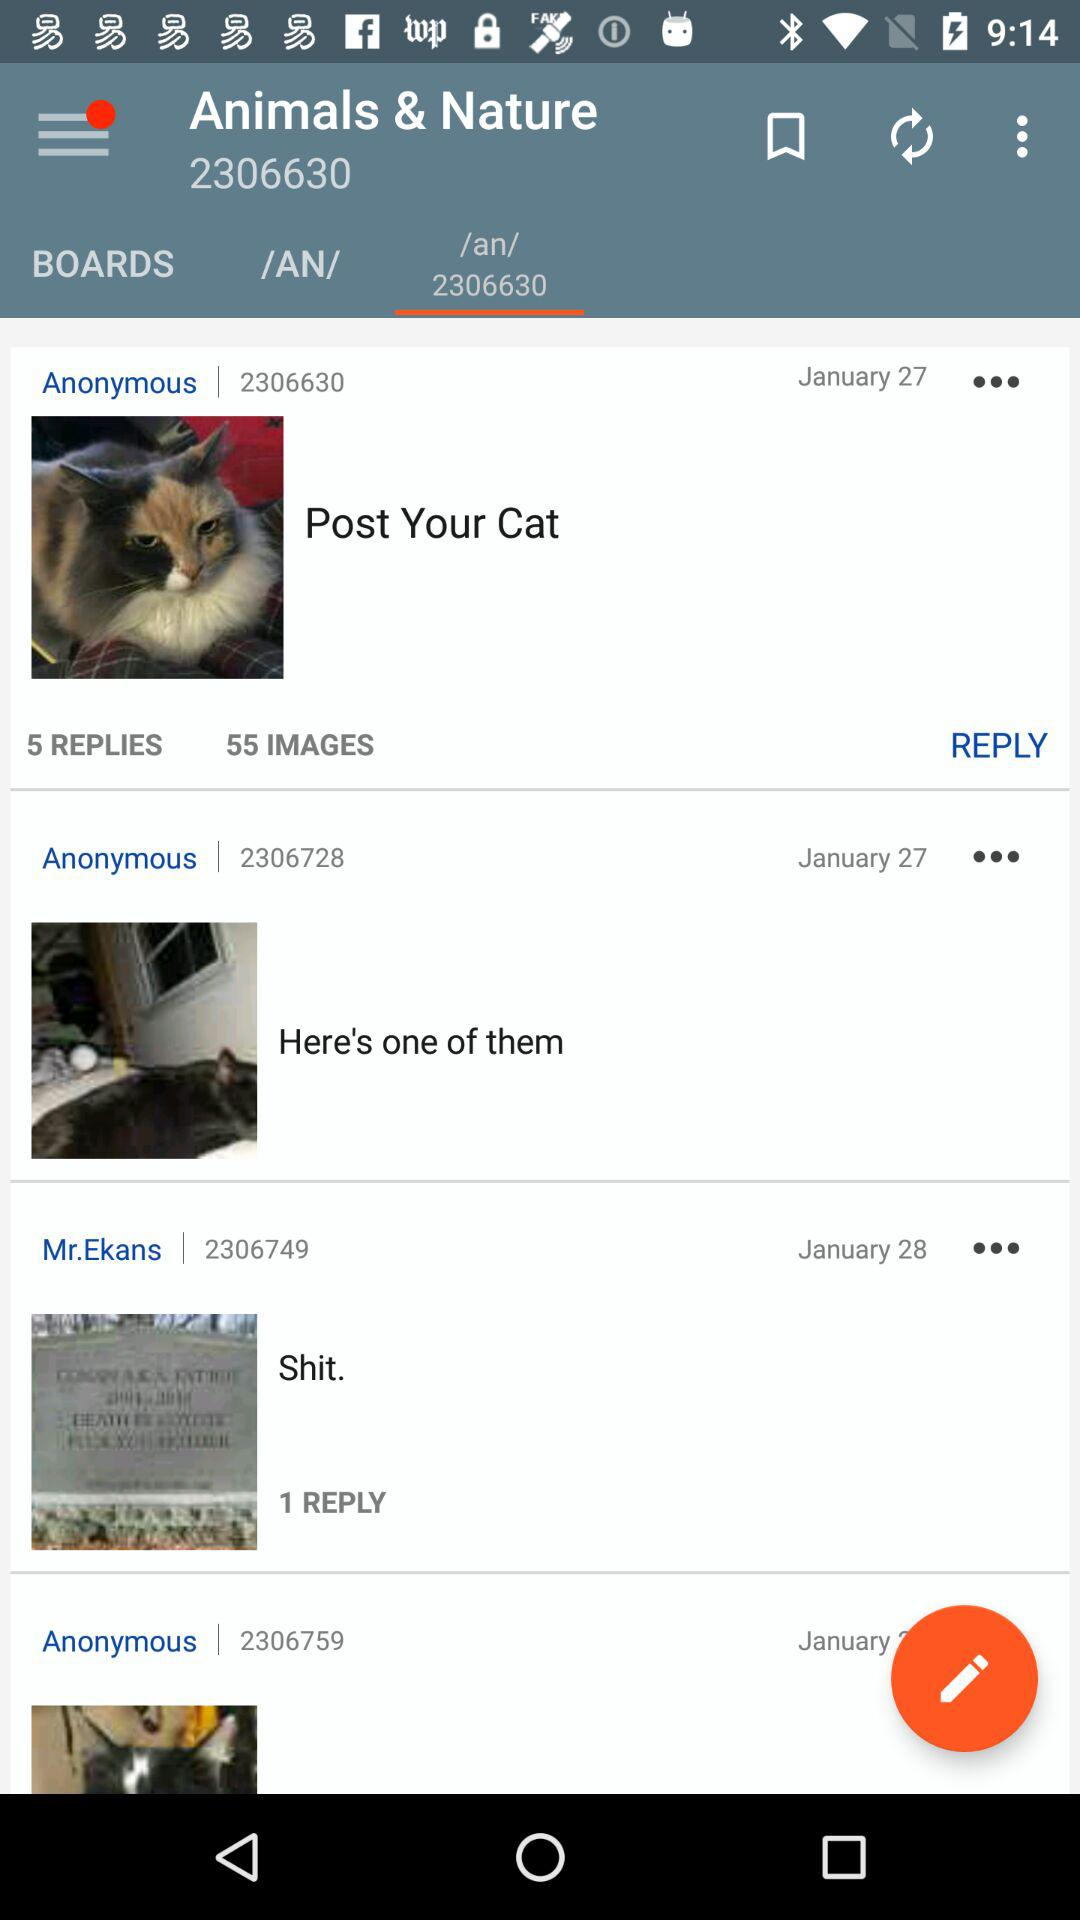On which date did Mr.Ekans share the post? Mr.Ekans shared the post on January 28. 